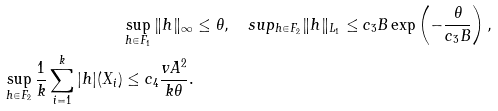Convert formula to latex. <formula><loc_0><loc_0><loc_500><loc_500>\sup _ { h \in F _ { 1 } } \| h \| _ { \infty } & \leq \theta , \quad s u p _ { h \in F _ { 2 } } \| h \| _ { L _ { 1 } } \leq c _ { 3 } B \exp \left ( - \frac { \theta } { c _ { 3 } B } \right ) , \\ \sup _ { h \in F _ { 2 } } \frac { 1 } { k } \sum _ { i = 1 } ^ { k } | h | ( X _ { i } ) \leq c _ { 4 } \frac { v A ^ { 2 } } { k \theta } .</formula> 